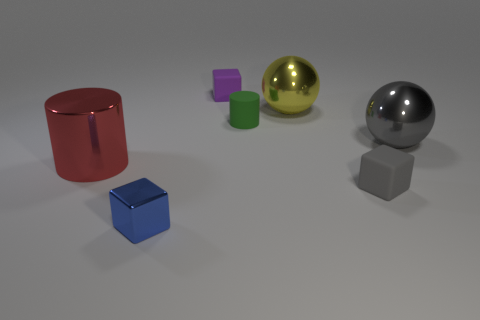How big is the matte block that is to the left of the gray rubber thing?
Your answer should be very brief. Small. There is a cylinder that is to the right of the small block that is to the left of the purple thing; how big is it?
Keep it short and to the point. Small. There is a red cylinder that is the same size as the yellow metal sphere; what is it made of?
Your answer should be very brief. Metal. There is a gray ball; are there any gray blocks on the left side of it?
Provide a short and direct response. Yes. Is the number of gray matte objects left of the tiny purple cube the same as the number of yellow cubes?
Give a very brief answer. Yes. There is a green matte object that is the same size as the purple rubber block; what shape is it?
Your answer should be very brief. Cylinder. What is the material of the big red cylinder?
Offer a very short reply. Metal. There is a metallic thing that is both left of the yellow object and on the right side of the red shiny object; what is its color?
Offer a terse response. Blue. Are there the same number of yellow metallic things that are left of the purple block and big things that are behind the big gray shiny ball?
Provide a short and direct response. No. What color is the cylinder that is made of the same material as the blue cube?
Offer a terse response. Red. 